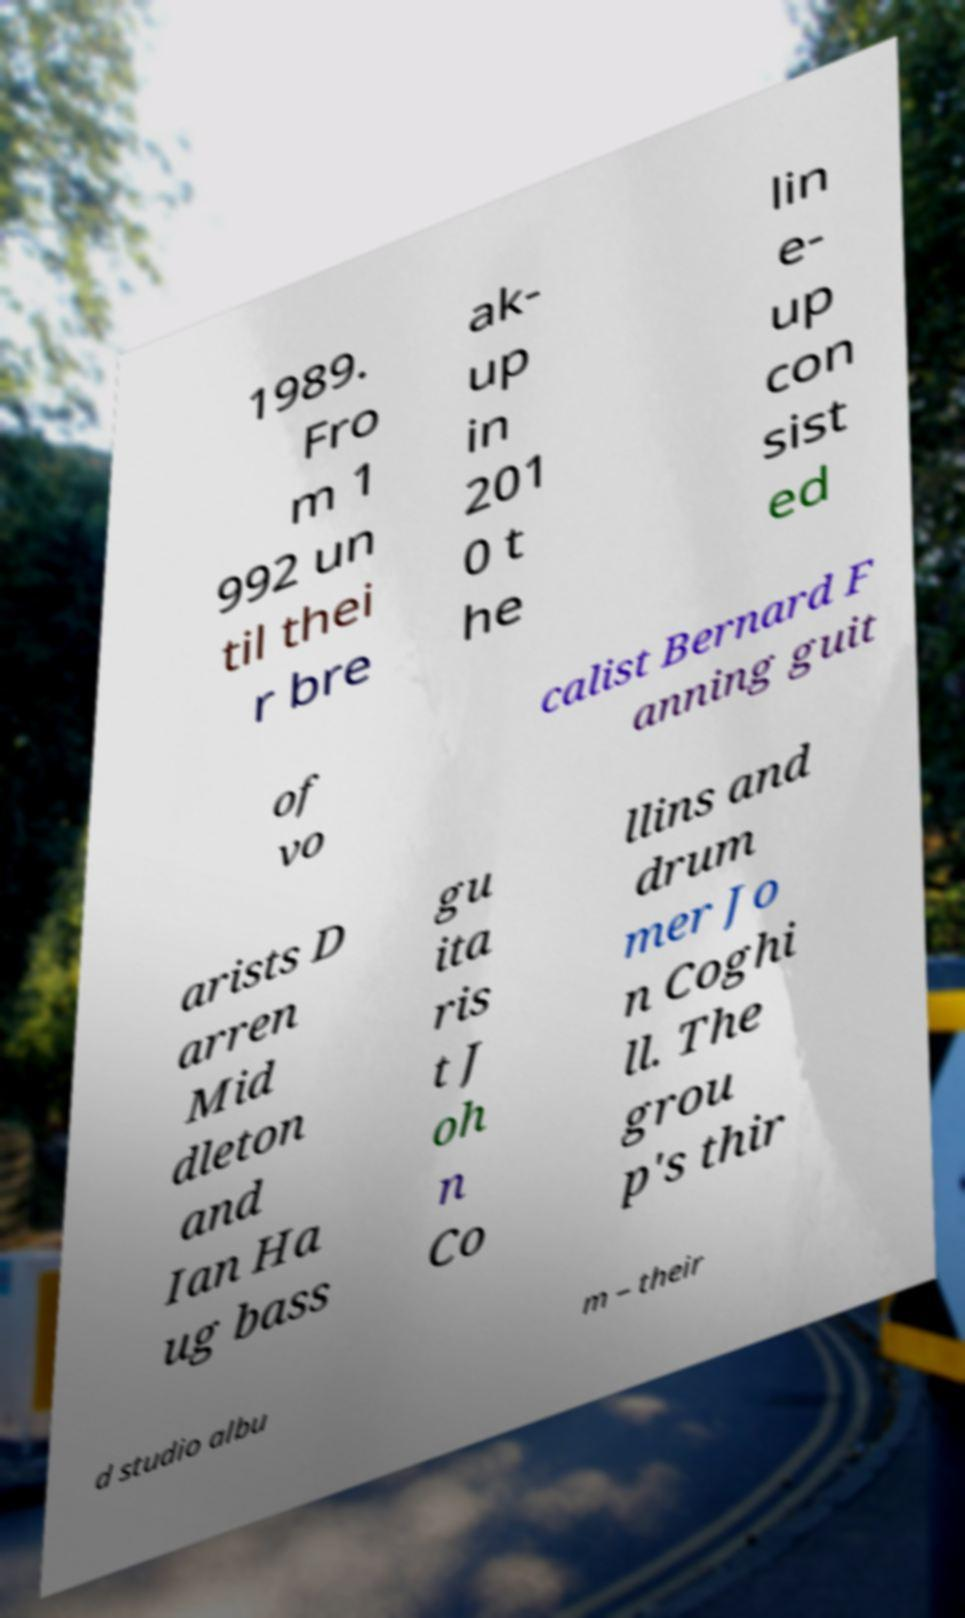I need the written content from this picture converted into text. Can you do that? 1989. Fro m 1 992 un til thei r bre ak- up in 201 0 t he lin e- up con sist ed of vo calist Bernard F anning guit arists D arren Mid dleton and Ian Ha ug bass gu ita ris t J oh n Co llins and drum mer Jo n Coghi ll. The grou p's thir d studio albu m – their 